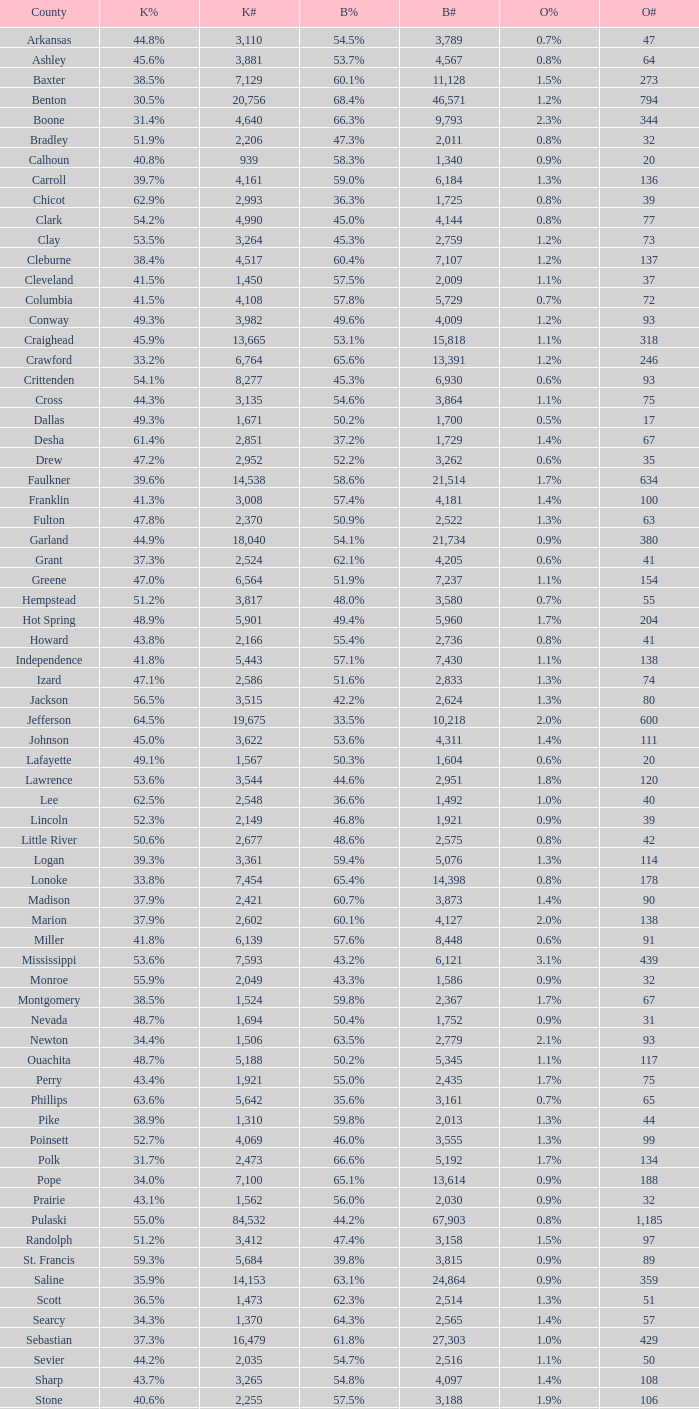What is the highest Bush#, when Others% is "1.7%", when Others# is less than 75, and when Kerry# is greater than 1,524? None. 